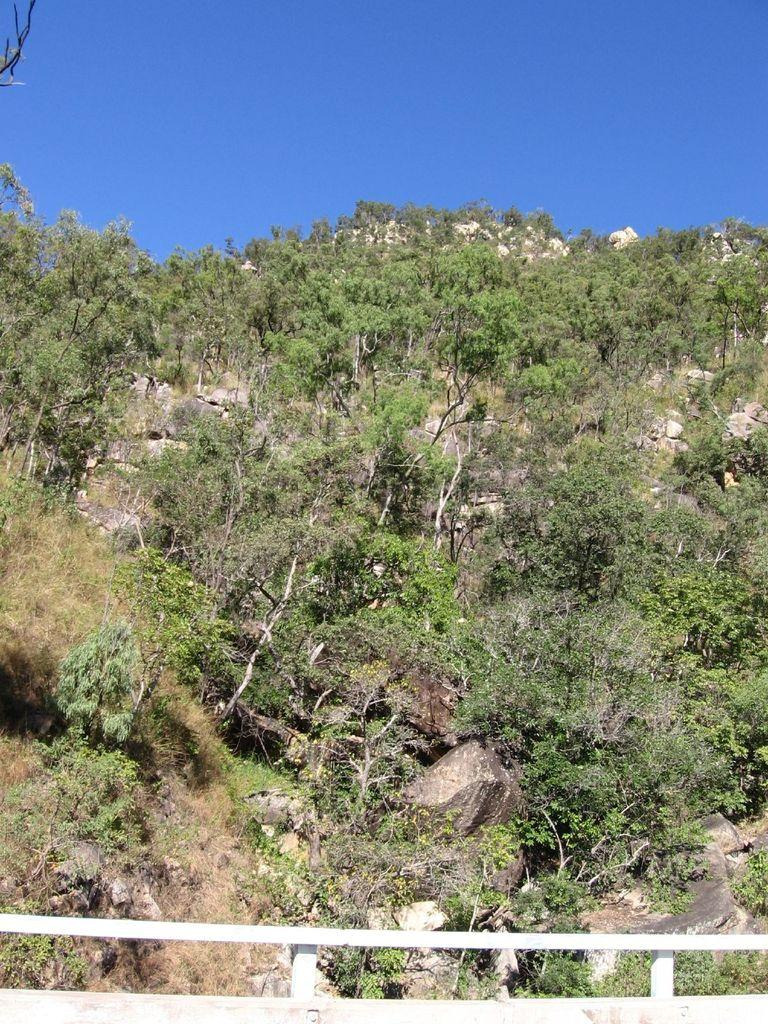What type of vegetation can be seen in the image? There are plants and trees in the image. What is the color of the railing in the image? The railing in the image is white. What is located in the background of the image? There is a hill and the sky visible in the background of the image. What type of credit card is being used to purchase the plants in the image? There is no credit card or purchase activity depicted in the image; it only shows plants, trees, a white railing, a hill, and the sky. 